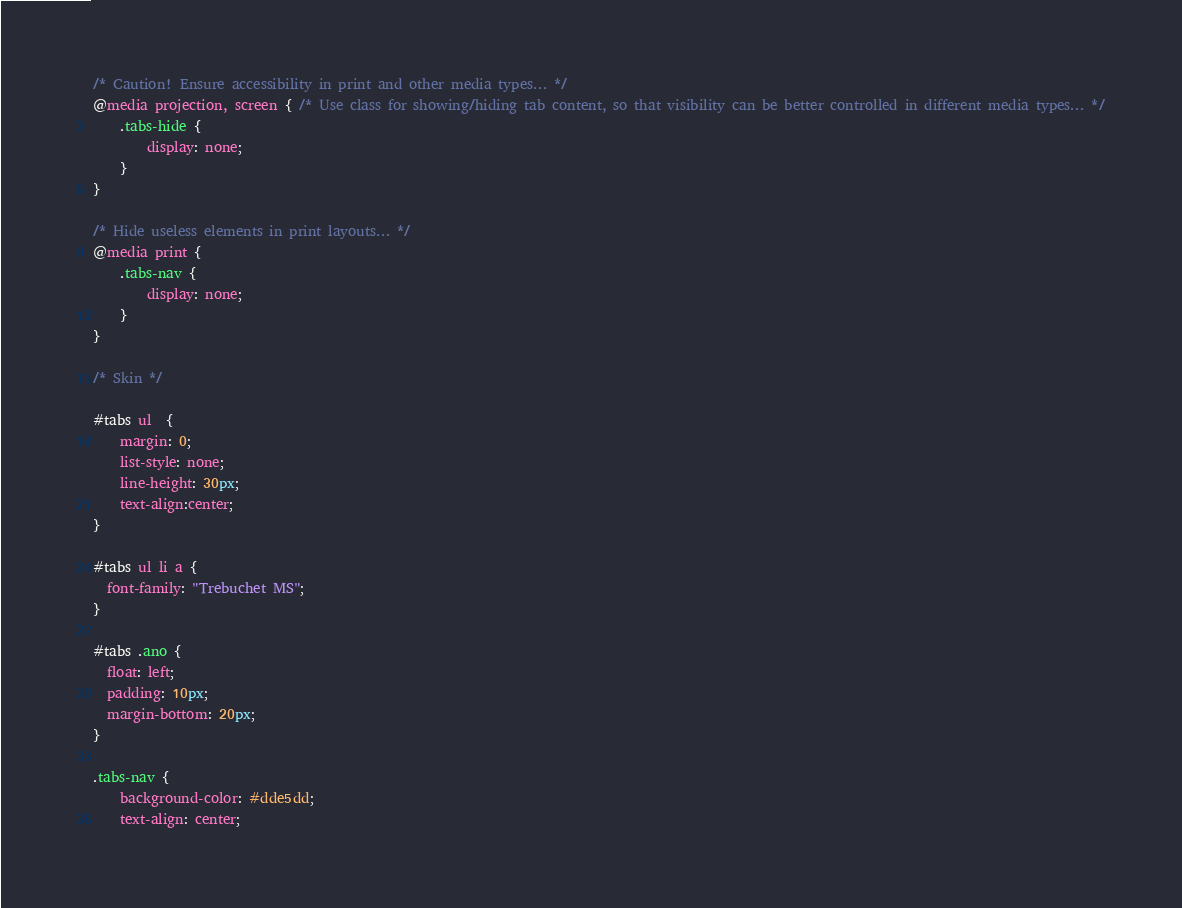<code> <loc_0><loc_0><loc_500><loc_500><_CSS_>/* Caution! Ensure accessibility in print and other media types... */
@media projection, screen { /* Use class for showing/hiding tab content, so that visibility can be better controlled in different media types... */
    .tabs-hide {
        display: none;
    }
}

/* Hide useless elements in print layouts... */
@media print {
    .tabs-nav {
        display: none;
    }
}

/* Skin */

#tabs ul  {
	margin: 0;
	list-style: none;
	line-height: 30px;
	text-align:center;
}

#tabs ul li a {
  font-family: "Trebuchet MS";
}

#tabs .ano {
  float: left;
  padding: 10px;
  margin-bottom: 20px;
}

.tabs-nav {
    background-color: #dde5dd;
    text-align: center;</code> 